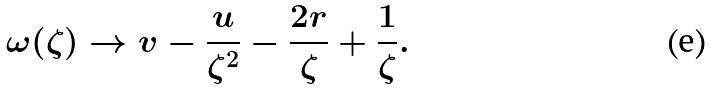<formula> <loc_0><loc_0><loc_500><loc_500>\omega ( \zeta ) \to v - \frac { u } { \zeta ^ { 2 } } - \frac { 2 r } { \zeta } + \frac { 1 } { \zeta } .</formula> 